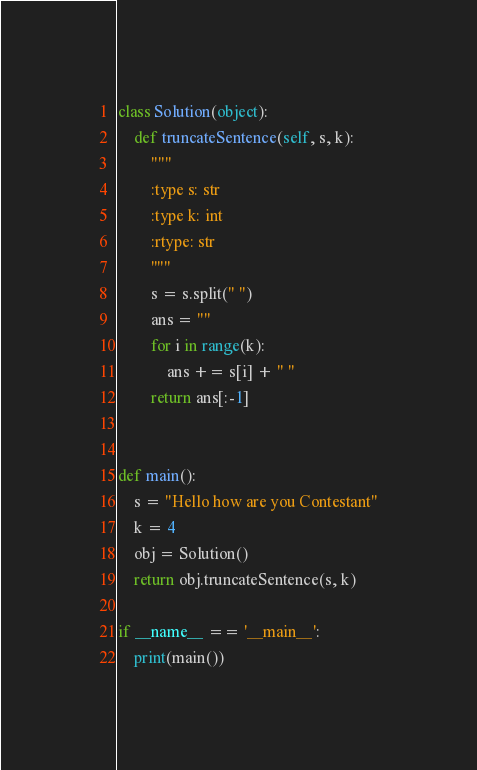<code> <loc_0><loc_0><loc_500><loc_500><_Python_>class Solution(object):
    def truncateSentence(self, s, k):
        """
        :type s: str
        :type k: int
        :rtype: str
        """
        s = s.split(" ")
        ans = ""
        for i in range(k):
            ans += s[i] + " "
        return ans[:-1]


def main():
    s = "Hello how are you Contestant"
    k = 4
    obj = Solution()
    return obj.truncateSentence(s, k)

if __name__ == '__main__':
    print(main())
</code> 